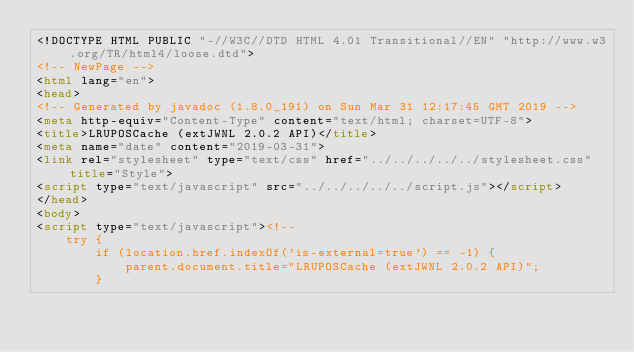<code> <loc_0><loc_0><loc_500><loc_500><_HTML_><!DOCTYPE HTML PUBLIC "-//W3C//DTD HTML 4.01 Transitional//EN" "http://www.w3.org/TR/html4/loose.dtd">
<!-- NewPage -->
<html lang="en">
<head>
<!-- Generated by javadoc (1.8.0_191) on Sun Mar 31 12:17:45 GMT 2019 -->
<meta http-equiv="Content-Type" content="text/html; charset=UTF-8">
<title>LRUPOSCache (extJWNL 2.0.2 API)</title>
<meta name="date" content="2019-03-31">
<link rel="stylesheet" type="text/css" href="../../../../../stylesheet.css" title="Style">
<script type="text/javascript" src="../../../../../script.js"></script>
</head>
<body>
<script type="text/javascript"><!--
    try {
        if (location.href.indexOf('is-external=true') == -1) {
            parent.document.title="LRUPOSCache (extJWNL 2.0.2 API)";
        }</code> 